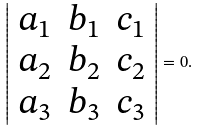Convert formula to latex. <formula><loc_0><loc_0><loc_500><loc_500>\left | { \begin{array} { l l l } { a _ { 1 } } & { b _ { 1 } } & { c _ { 1 } } \\ { a _ { 2 } } & { b _ { 2 } } & { c _ { 2 } } \\ { a _ { 3 } } & { b _ { 3 } } & { c _ { 3 } } \end{array} } \right | = 0 .</formula> 